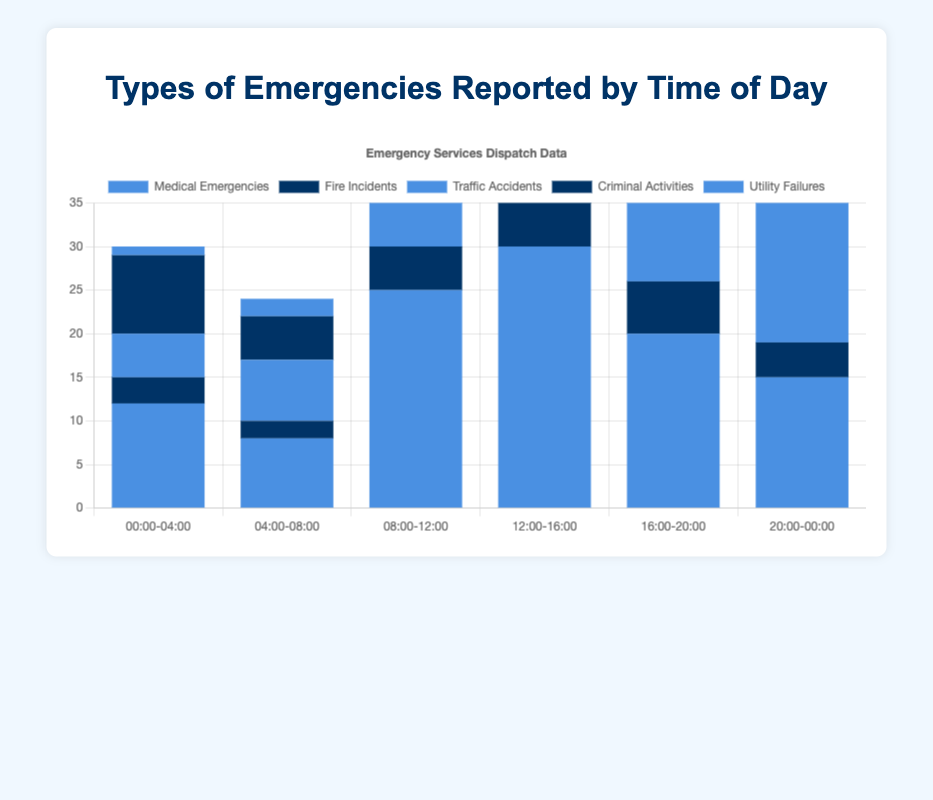What type of emergency is most frequently reported between 12:00-16:00? Looking at the bar chart for the 12:00-16:00 time slot, the highest bar corresponds to Medical Emergencies with a height of 30.
Answer: Medical Emergencies Which type of emergency has the least number of incidents reported between 00:00-04:00 and 04:00-08:00 combined? Add the incidents for each type between 00:00-04:00 and 04:00-08:00: Medical Emergencies (12+8=20), Fire Incidents (3+2=5), Traffic Accidents (5+7=12), Criminal Activities (9+5=14), Utility Failures (1+2=3). The lowest combined total is for Utility Failures.
Answer: Utility Failures During which time slot are Traffic Accidents reported more frequently than Fire Incidents but less frequently than Medical Emergencies? Compare the bar heights for Traffic Accidents, Fire Incidents, and Medical Emergencies for each time slot: from 08:00-12:00 (Traffic: 20, Fire: 5, Medical: 25) and from 16:00-20:00 (Traffic: 22, Fire: 6, Medical: 20). Both these slots satisfy the condition, so the first valid slot is 08:00-12:00.
Answer: 08:00-12:00 What is the total number of incidents reported between 20:00-00:00 for all types of emergencies combined? Sum the incidents for each type between 20:00-00:00: Medical Emergencies (15), Fire Incidents (4), Traffic Accidents (16), Criminal Activities (10), Utility Failures (2). 15+4+16+10+2 = 47.
Answer: 47 Between 16:00-20:00, how many more Traffic Accidents are reported compared to Criminal Activities? Subtract the number of Criminal Activities (12) from the number of Traffic Accidents (22) between 16:00-20:00. 22-12 = 10.
Answer: 10 During which time slot are the total number of incidents across all types the highest? Sum the incidents for each time slot to find the highest total: (00:00-04:00 = 30, 04:00-08:00 = 24, 08:00-12:00 = 63, 12:00-16:00 = 76, 16:00-20:00 = 63, 20:00-00:00 = 47). The highest total is 76 for 12:00-16:00.
Answer: 12:00-16:00 Which type of emergency is most consistently reported throughout the day with little variation in numbers? Examine the bars for each type across all time slots. Fire Incidents show the least variation, ranging only from 2 to 7 incidents.
Answer: Fire Incidents How many total Medical Emergencies are reported throughout the day? Add the incidents reported for Medical Emergencies across all time slots: 12+8+25+30+20+15 = 110.
Answer: 110 